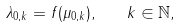Convert formula to latex. <formula><loc_0><loc_0><loc_500><loc_500>\lambda _ { 0 , k } = f ( \mu _ { 0 , k } ) , \quad k \in { \mathbb { N } } ,</formula> 